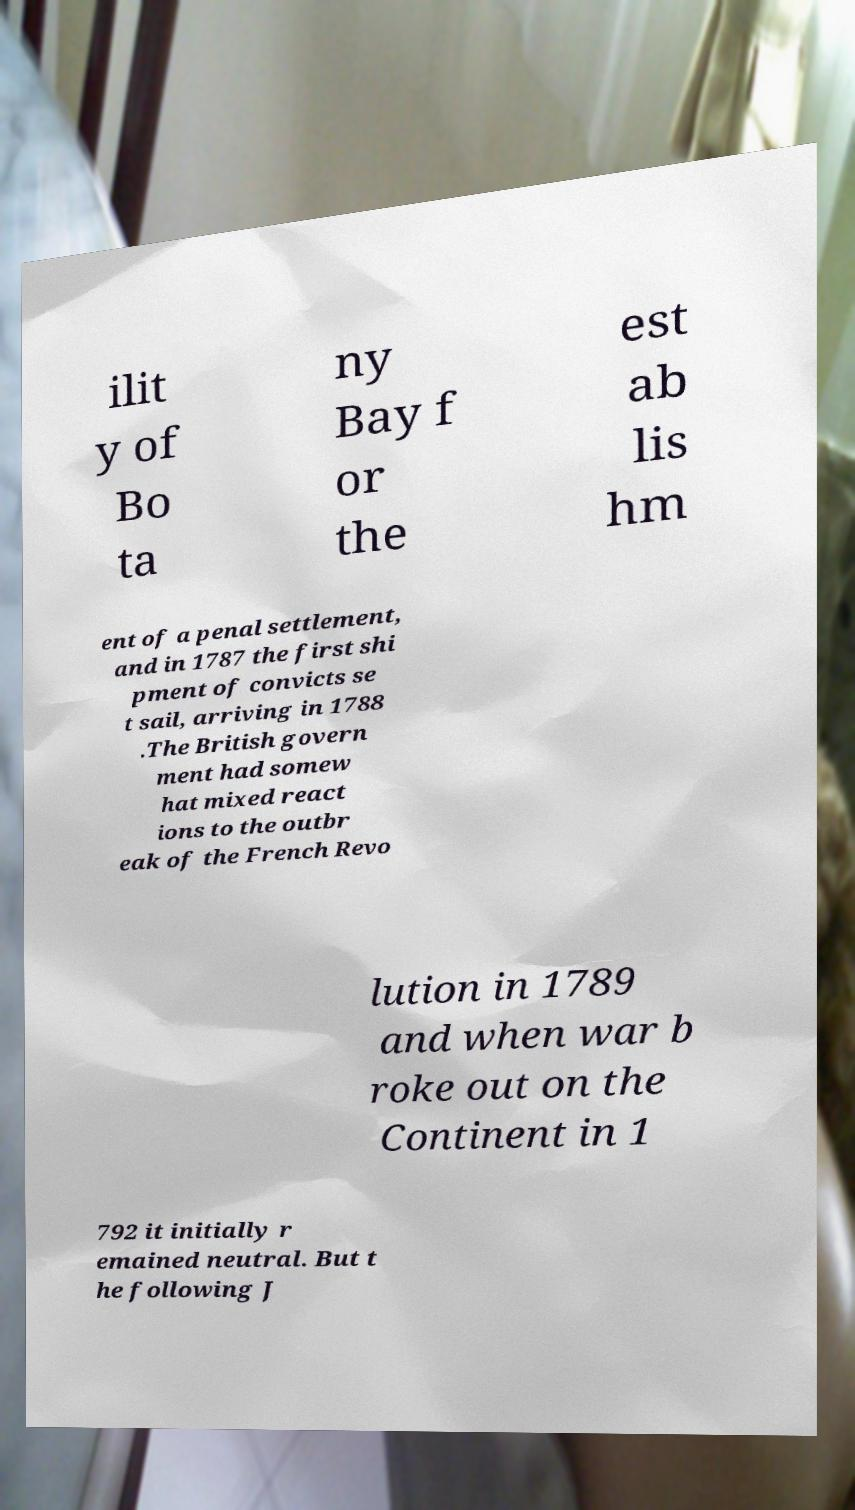Could you assist in decoding the text presented in this image and type it out clearly? ilit y of Bo ta ny Bay f or the est ab lis hm ent of a penal settlement, and in 1787 the first shi pment of convicts se t sail, arriving in 1788 .The British govern ment had somew hat mixed react ions to the outbr eak of the French Revo lution in 1789 and when war b roke out on the Continent in 1 792 it initially r emained neutral. But t he following J 